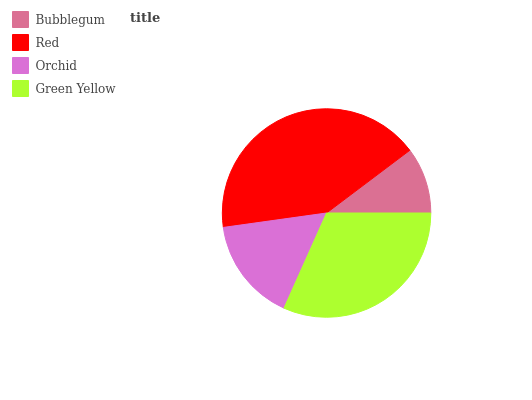Is Bubblegum the minimum?
Answer yes or no. Yes. Is Red the maximum?
Answer yes or no. Yes. Is Orchid the minimum?
Answer yes or no. No. Is Orchid the maximum?
Answer yes or no. No. Is Red greater than Orchid?
Answer yes or no. Yes. Is Orchid less than Red?
Answer yes or no. Yes. Is Orchid greater than Red?
Answer yes or no. No. Is Red less than Orchid?
Answer yes or no. No. Is Green Yellow the high median?
Answer yes or no. Yes. Is Orchid the low median?
Answer yes or no. Yes. Is Bubblegum the high median?
Answer yes or no. No. Is Green Yellow the low median?
Answer yes or no. No. 